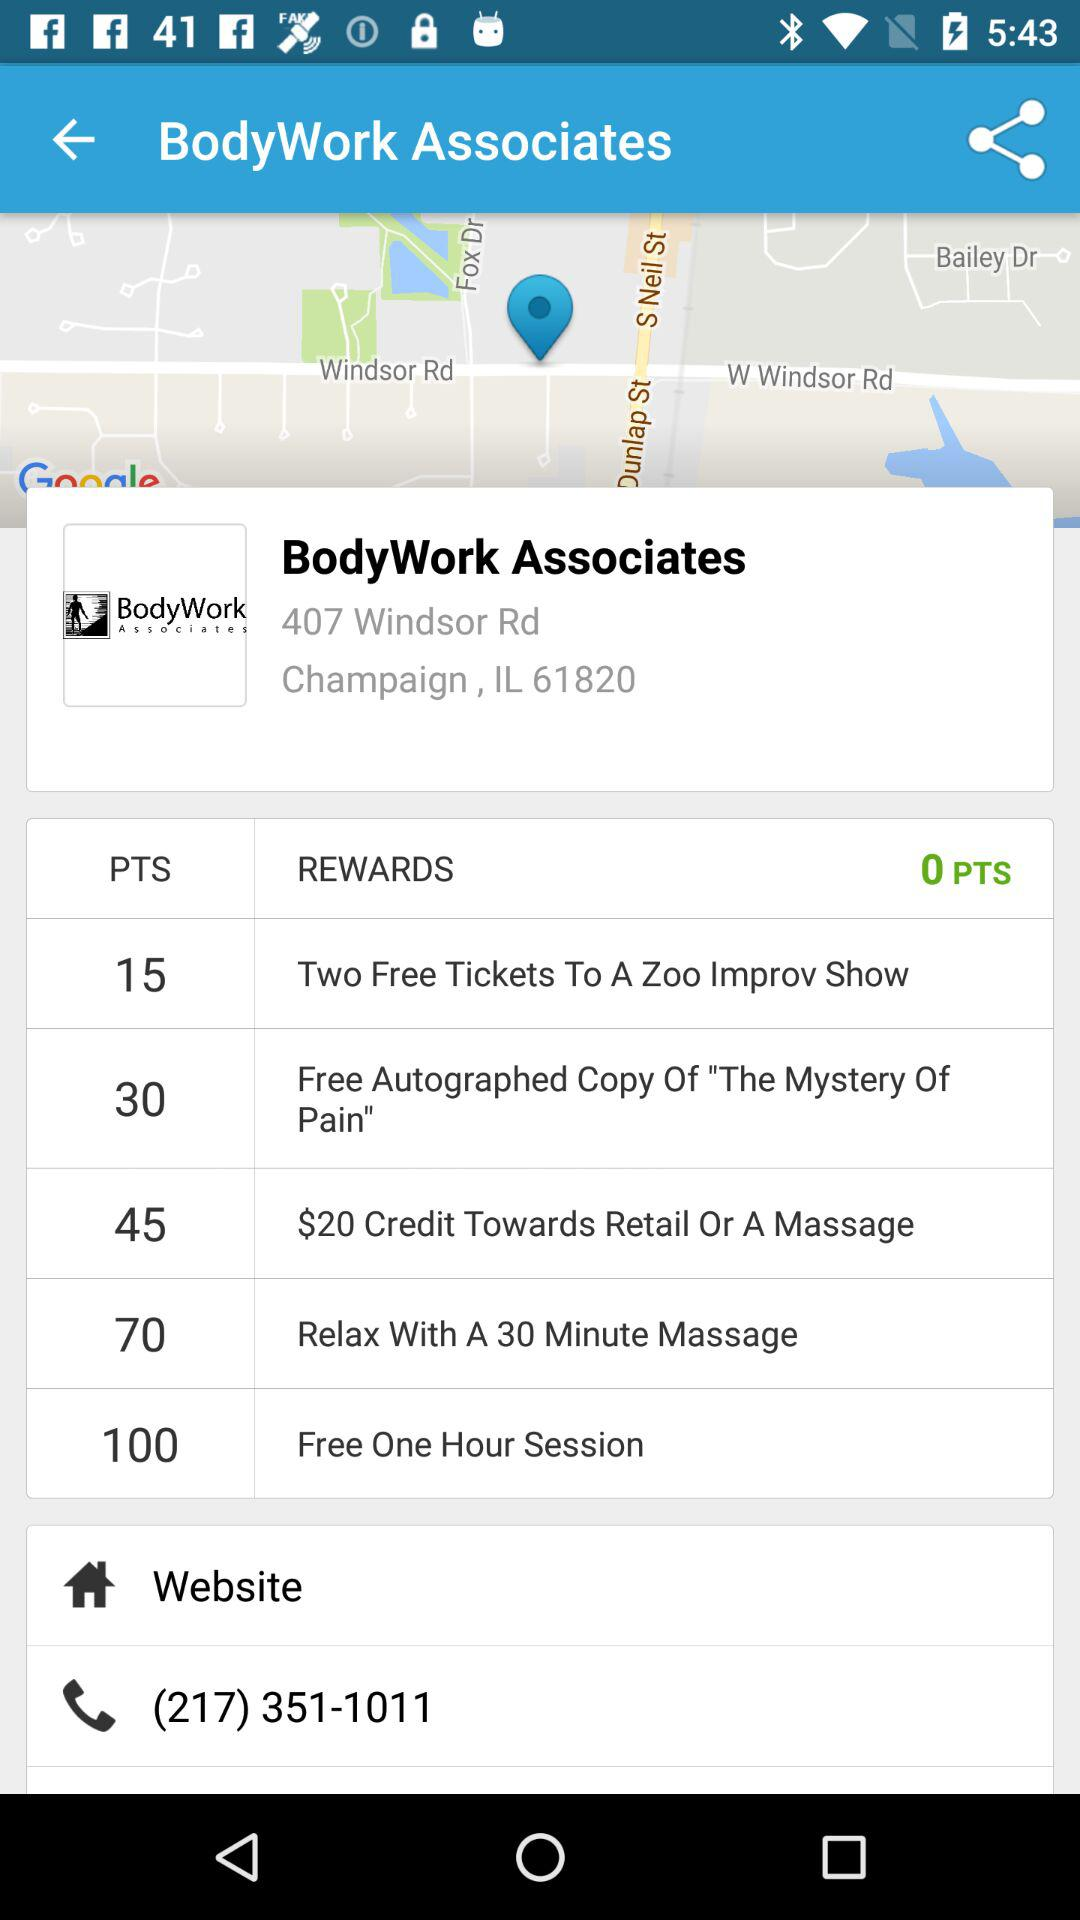What is the location? The location is 407 Windsor Rd., Champaign, IL 61820. 